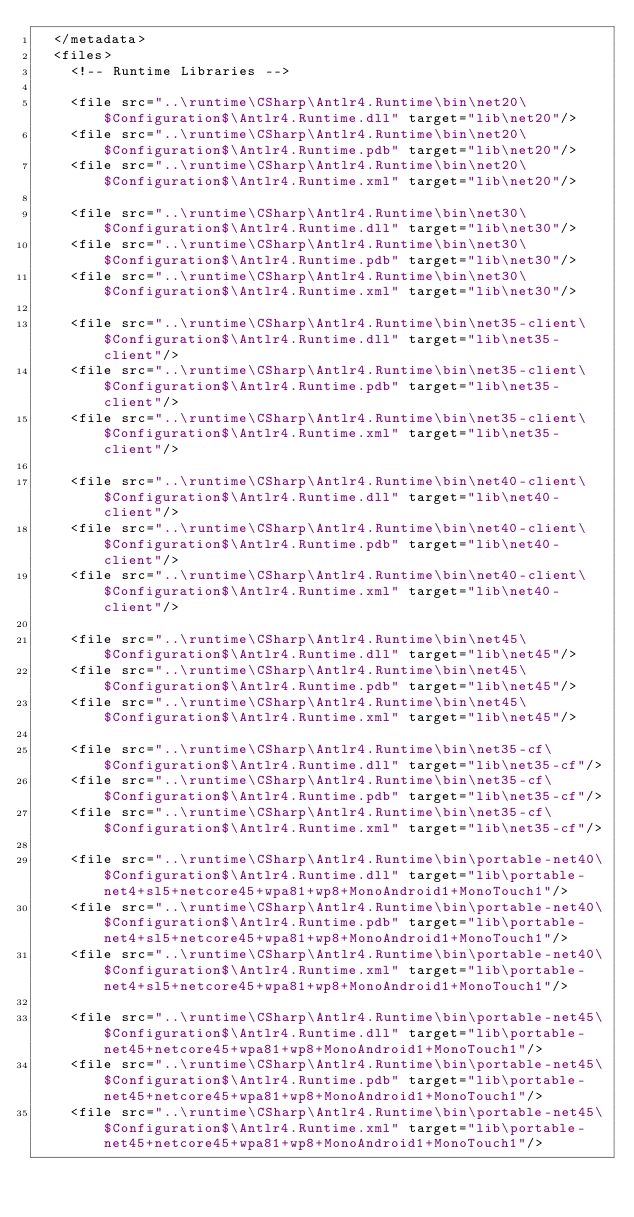Convert code to text. <code><loc_0><loc_0><loc_500><loc_500><_XML_>  </metadata>
  <files>
    <!-- Runtime Libraries -->

    <file src="..\runtime\CSharp\Antlr4.Runtime\bin\net20\$Configuration$\Antlr4.Runtime.dll" target="lib\net20"/>
    <file src="..\runtime\CSharp\Antlr4.Runtime\bin\net20\$Configuration$\Antlr4.Runtime.pdb" target="lib\net20"/>
    <file src="..\runtime\CSharp\Antlr4.Runtime\bin\net20\$Configuration$\Antlr4.Runtime.xml" target="lib\net20"/>

    <file src="..\runtime\CSharp\Antlr4.Runtime\bin\net30\$Configuration$\Antlr4.Runtime.dll" target="lib\net30"/>
    <file src="..\runtime\CSharp\Antlr4.Runtime\bin\net30\$Configuration$\Antlr4.Runtime.pdb" target="lib\net30"/>
    <file src="..\runtime\CSharp\Antlr4.Runtime\bin\net30\$Configuration$\Antlr4.Runtime.xml" target="lib\net30"/>

    <file src="..\runtime\CSharp\Antlr4.Runtime\bin\net35-client\$Configuration$\Antlr4.Runtime.dll" target="lib\net35-client"/>
    <file src="..\runtime\CSharp\Antlr4.Runtime\bin\net35-client\$Configuration$\Antlr4.Runtime.pdb" target="lib\net35-client"/>
    <file src="..\runtime\CSharp\Antlr4.Runtime\bin\net35-client\$Configuration$\Antlr4.Runtime.xml" target="lib\net35-client"/>

    <file src="..\runtime\CSharp\Antlr4.Runtime\bin\net40-client\$Configuration$\Antlr4.Runtime.dll" target="lib\net40-client"/>
    <file src="..\runtime\CSharp\Antlr4.Runtime\bin\net40-client\$Configuration$\Antlr4.Runtime.pdb" target="lib\net40-client"/>
    <file src="..\runtime\CSharp\Antlr4.Runtime\bin\net40-client\$Configuration$\Antlr4.Runtime.xml" target="lib\net40-client"/>

    <file src="..\runtime\CSharp\Antlr4.Runtime\bin\net45\$Configuration$\Antlr4.Runtime.dll" target="lib\net45"/>
    <file src="..\runtime\CSharp\Antlr4.Runtime\bin\net45\$Configuration$\Antlr4.Runtime.pdb" target="lib\net45"/>
    <file src="..\runtime\CSharp\Antlr4.Runtime\bin\net45\$Configuration$\Antlr4.Runtime.xml" target="lib\net45"/>

    <file src="..\runtime\CSharp\Antlr4.Runtime\bin\net35-cf\$Configuration$\Antlr4.Runtime.dll" target="lib\net35-cf"/>
    <file src="..\runtime\CSharp\Antlr4.Runtime\bin\net35-cf\$Configuration$\Antlr4.Runtime.pdb" target="lib\net35-cf"/>
    <file src="..\runtime\CSharp\Antlr4.Runtime\bin\net35-cf\$Configuration$\Antlr4.Runtime.xml" target="lib\net35-cf"/>

    <file src="..\runtime\CSharp\Antlr4.Runtime\bin\portable-net40\$Configuration$\Antlr4.Runtime.dll" target="lib\portable-net4+sl5+netcore45+wpa81+wp8+MonoAndroid1+MonoTouch1"/>
    <file src="..\runtime\CSharp\Antlr4.Runtime\bin\portable-net40\$Configuration$\Antlr4.Runtime.pdb" target="lib\portable-net4+sl5+netcore45+wpa81+wp8+MonoAndroid1+MonoTouch1"/>
    <file src="..\runtime\CSharp\Antlr4.Runtime\bin\portable-net40\$Configuration$\Antlr4.Runtime.xml" target="lib\portable-net4+sl5+netcore45+wpa81+wp8+MonoAndroid1+MonoTouch1"/>

    <file src="..\runtime\CSharp\Antlr4.Runtime\bin\portable-net45\$Configuration$\Antlr4.Runtime.dll" target="lib\portable-net45+netcore45+wpa81+wp8+MonoAndroid1+MonoTouch1"/>
    <file src="..\runtime\CSharp\Antlr4.Runtime\bin\portable-net45\$Configuration$\Antlr4.Runtime.pdb" target="lib\portable-net45+netcore45+wpa81+wp8+MonoAndroid1+MonoTouch1"/>
    <file src="..\runtime\CSharp\Antlr4.Runtime\bin\portable-net45\$Configuration$\Antlr4.Runtime.xml" target="lib\portable-net45+netcore45+wpa81+wp8+MonoAndroid1+MonoTouch1"/>
</code> 